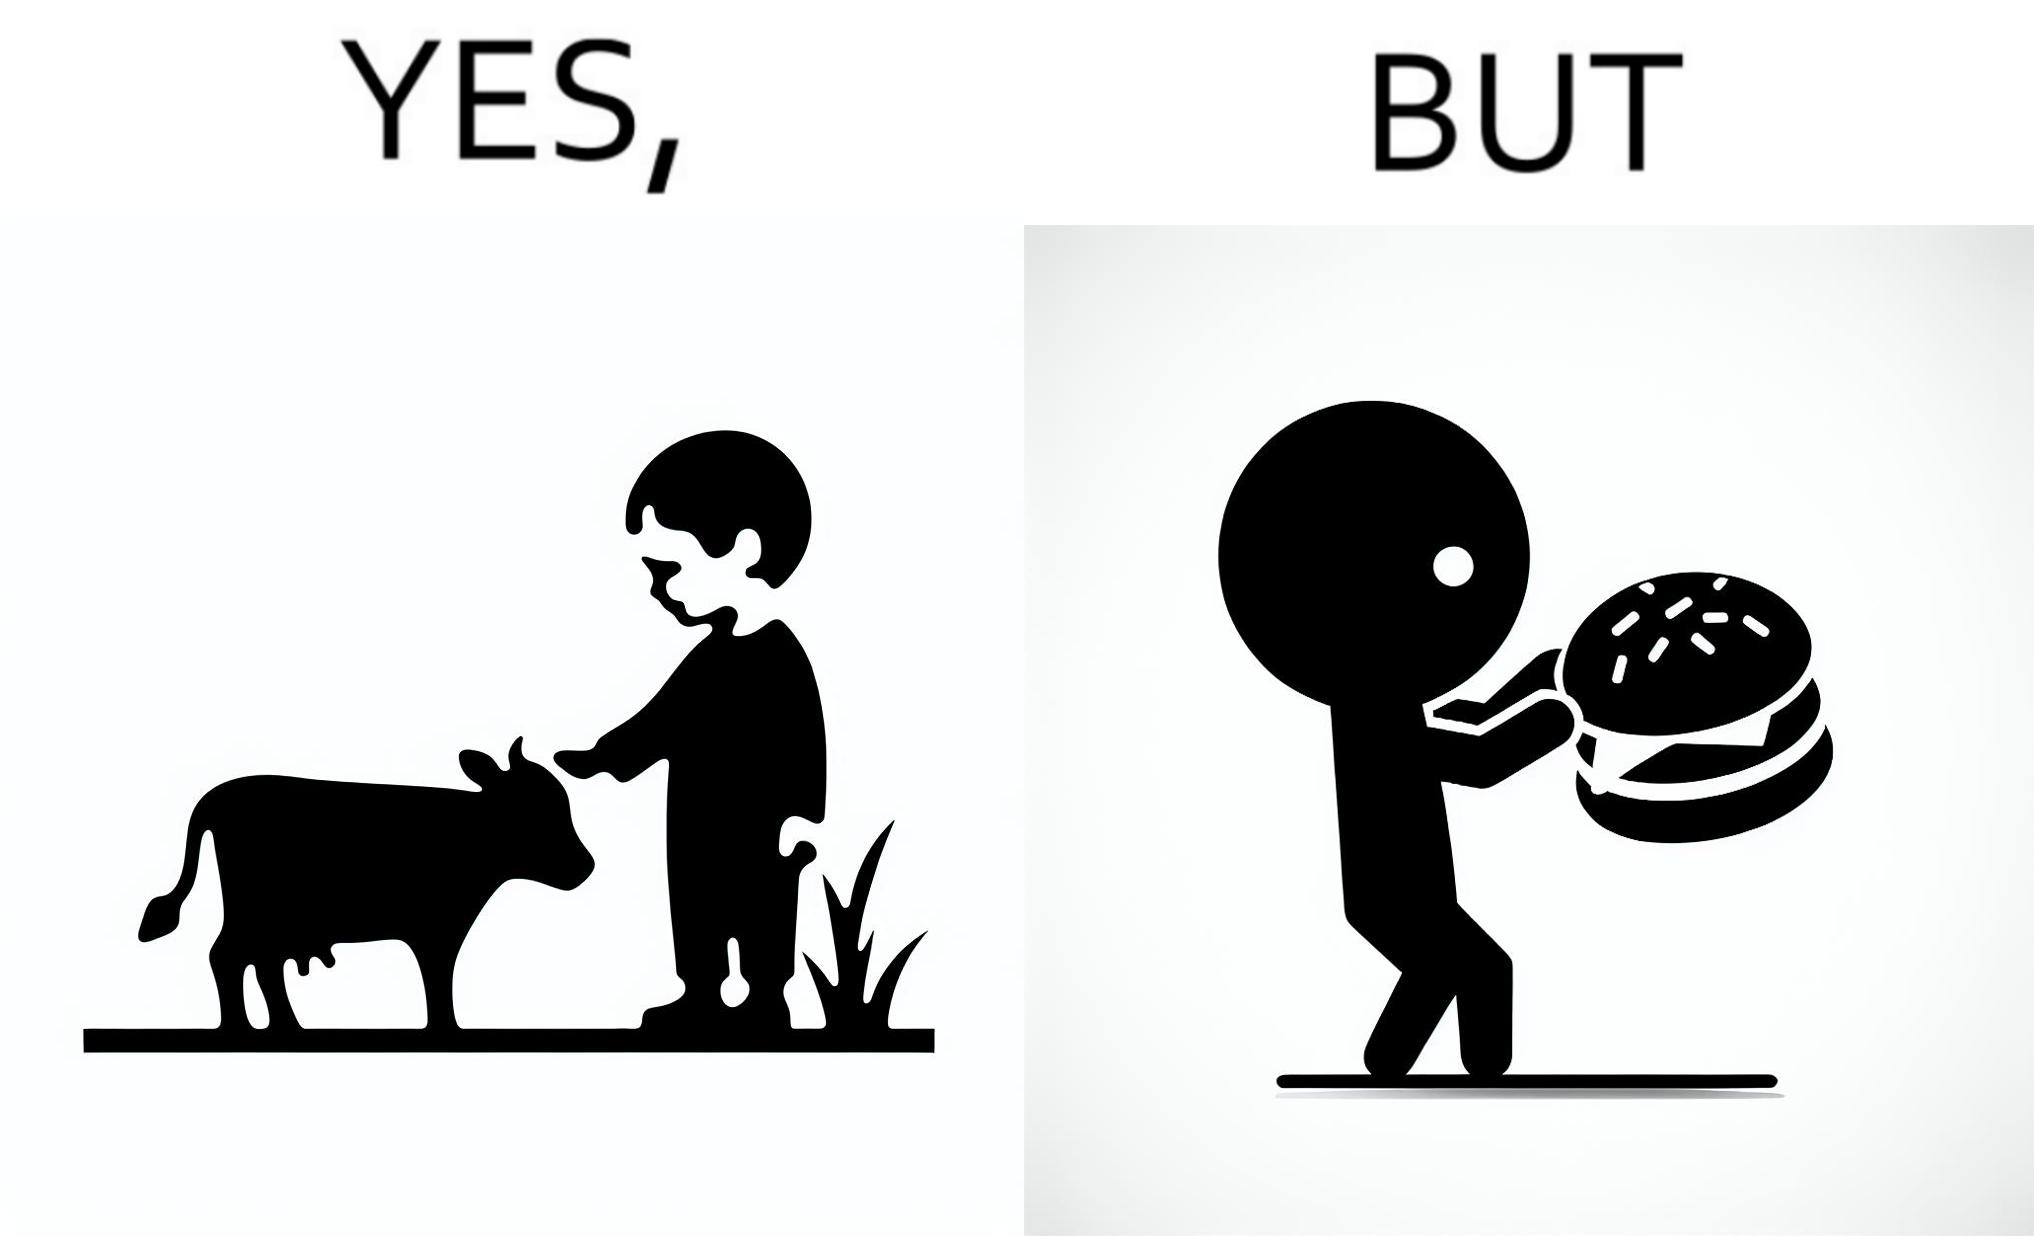Compare the left and right sides of this image. In the left part of the image: A boy petting a cow In the right part of the image: A boy eating a hamburger 